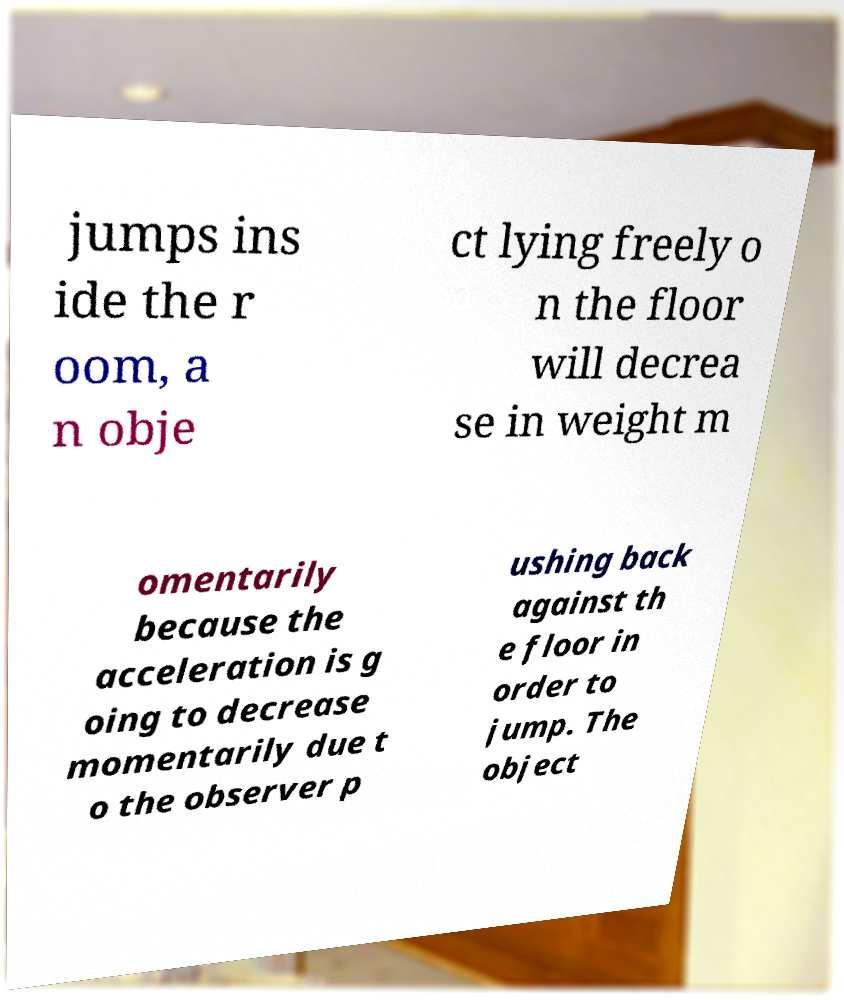I need the written content from this picture converted into text. Can you do that? jumps ins ide the r oom, a n obje ct lying freely o n the floor will decrea se in weight m omentarily because the acceleration is g oing to decrease momentarily due t o the observer p ushing back against th e floor in order to jump. The object 